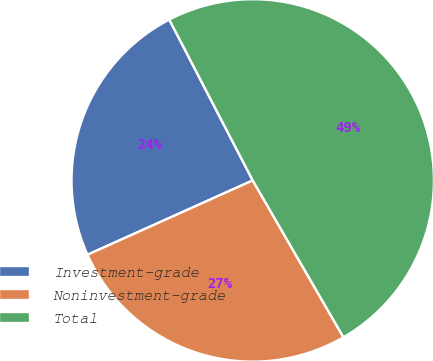<chart> <loc_0><loc_0><loc_500><loc_500><pie_chart><fcel>Investment-grade<fcel>Noninvestment-grade<fcel>Total<nl><fcel>24.11%<fcel>26.62%<fcel>49.27%<nl></chart> 